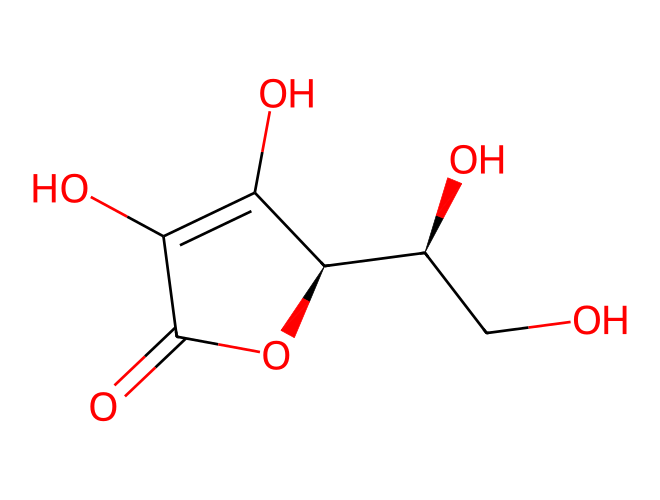What is the molecular formula of vitamin C based on the SMILES representation? Analyzing the SMILES structure, we can identify the individual atoms present: it contains 6 carbon atoms, 8 hydrogen atoms, and 6 oxygen atoms. Thus, the molecular formula is C6H8O6.
Answer: C6H8O6 How many oxygen atoms are present in the structure of vitamin C? By examining the SMILES representation, we can count the number of oxygen atoms explicitly, which are represented by the 'O' in the structure. There are 6 oxygen atoms in total.
Answer: 6 What type of functional groups are present in vitamin C? In reviewing the chemical structure, we can identify hydroxyl (-OH) groups and a carbonyl (C=O) group. These groups are characteristic of alcohols and aldehydes, respectively, which are functional groups present in vitamin C.
Answer: hydroxyl and carbonyl How does vitamin C contribute to collagen synthesis? Vitamin C acts as a cofactor for the enzymes prolyl and lysyl hydroxylase, which are responsible for the post-translational modification of collagen. This modification is essential for the stabilization of the collagen triple helix structure.
Answer: cofactor for collagen enzymes What is the stereochemistry of vitamin C? The SMILES representation includes symbols indicating chirality (C@H), showing that vitamin C has chiral centers in its structure. This means it exists as enantiomers due to the presence of these stereogenic centers.
Answer: chiral centers What is the role of vitamin C as an antioxidant? Vitamin C can donate electrons to neutralize free radicals, thereby preventing oxidative damage in cells. This specific action helps protect the body from stress caused by oxidative agents.
Answer: electron donor 